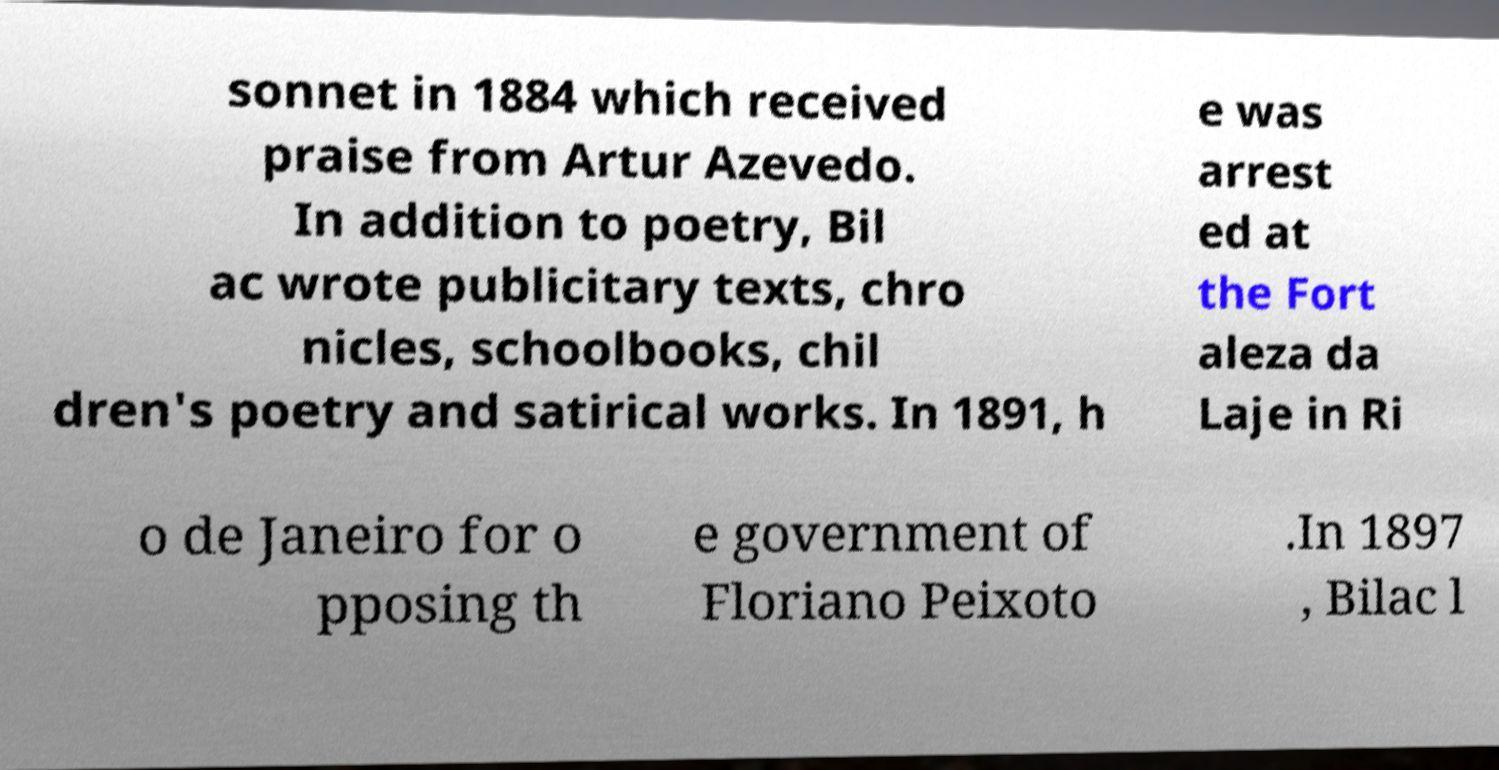Please identify and transcribe the text found in this image. sonnet in 1884 which received praise from Artur Azevedo. In addition to poetry, Bil ac wrote publicitary texts, chro nicles, schoolbooks, chil dren's poetry and satirical works. In 1891, h e was arrest ed at the Fort aleza da Laje in Ri o de Janeiro for o pposing th e government of Floriano Peixoto .In 1897 , Bilac l 